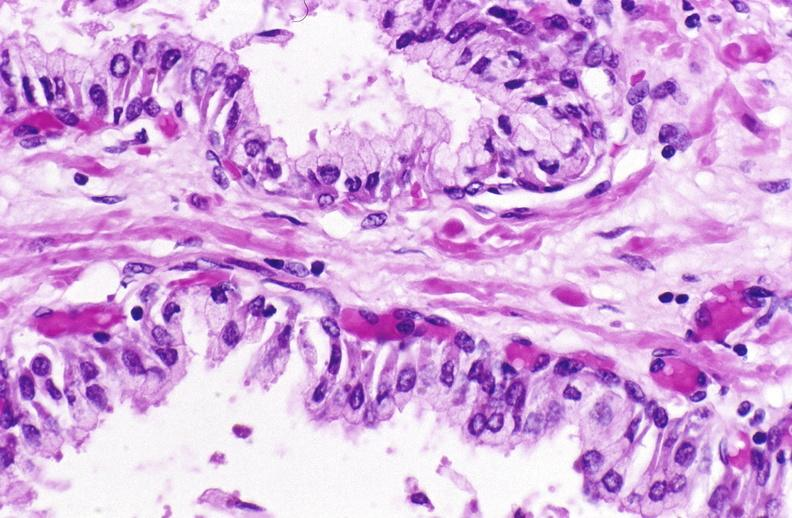what does this image show?
Answer the question using a single word or phrase. Normal prostate 